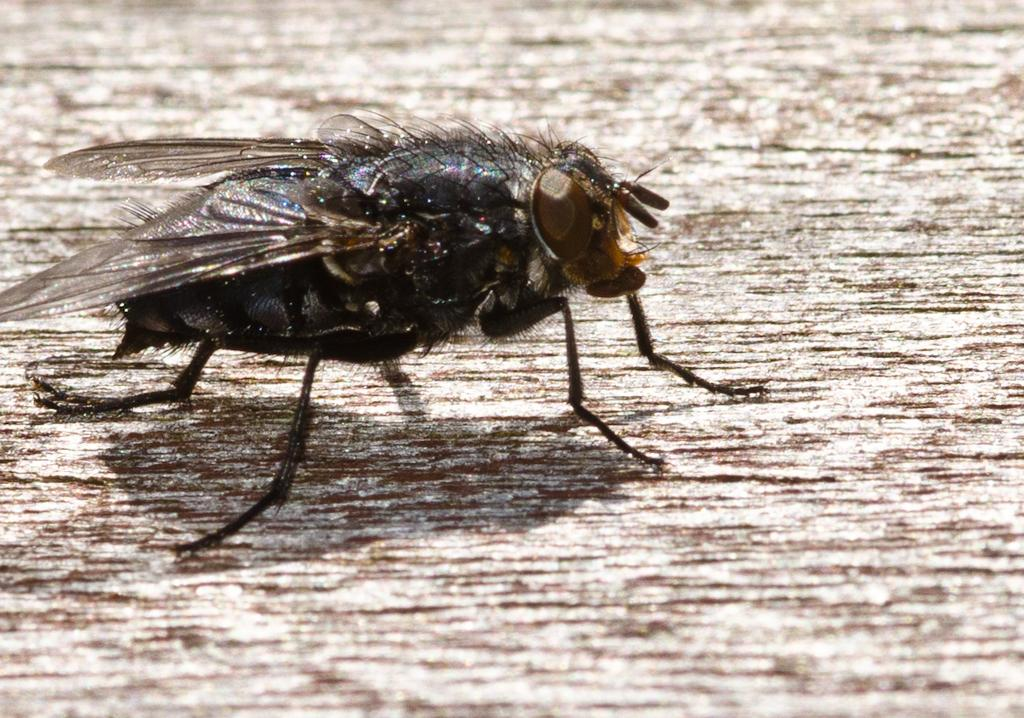What type of creature can be seen in the image? There is an insect in the image. Where is the insect located? The insect is sitting on a wooden surface. How many lines can be seen on the stick in the image? There is no stick present in the image, and therefore no lines can be observed. 